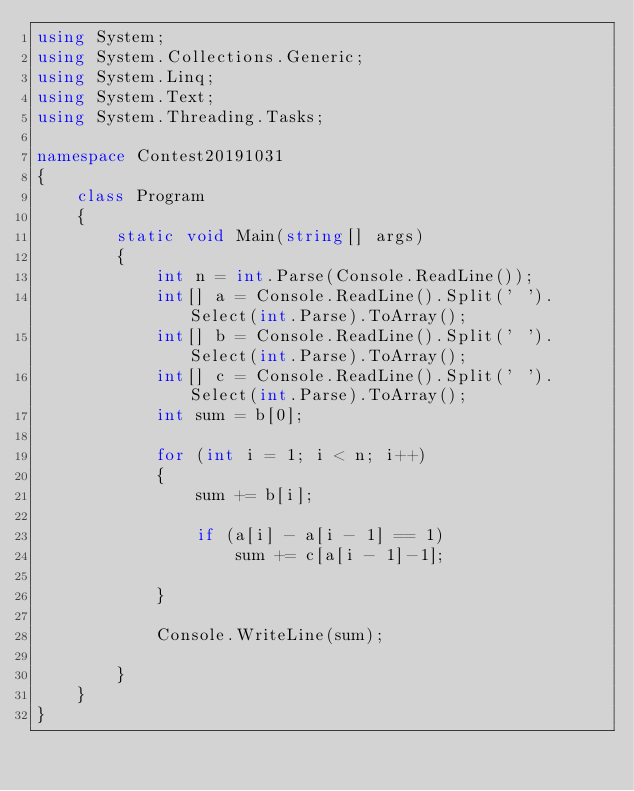<code> <loc_0><loc_0><loc_500><loc_500><_C#_>using System;
using System.Collections.Generic;
using System.Linq;
using System.Text;
using System.Threading.Tasks;

namespace Contest20191031
{
    class Program
    {
        static void Main(string[] args)
        {
            int n = int.Parse(Console.ReadLine());
            int[] a = Console.ReadLine().Split(' ').Select(int.Parse).ToArray();
            int[] b = Console.ReadLine().Split(' ').Select(int.Parse).ToArray();
            int[] c = Console.ReadLine().Split(' ').Select(int.Parse).ToArray();
            int sum = b[0];

            for (int i = 1; i < n; i++) 
            {
                sum += b[i];

                if (a[i] - a[i - 1] == 1)
                    sum += c[a[i - 1]-1];

            }

            Console.WriteLine(sum);

        }
    }
}
</code> 